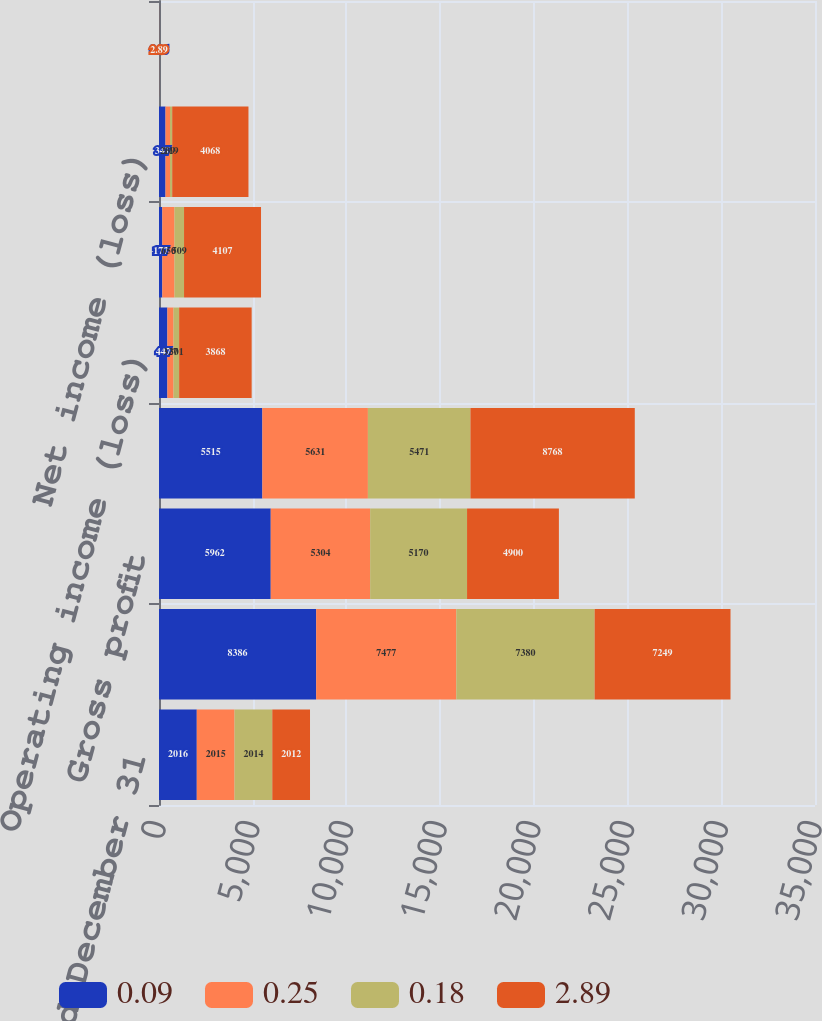Convert chart to OTSL. <chart><loc_0><loc_0><loc_500><loc_500><stacked_bar_chart><ecel><fcel>Year Ended December 31<fcel>Net sales<fcel>Gross profit<fcel>Total operating expenses<fcel>Operating income (loss)<fcel>Income (loss) before income<fcel>Net income (loss)<fcel>Basic<nl><fcel>0.09<fcel>2016<fcel>8386<fcel>5962<fcel>5515<fcel>447<fcel>177<fcel>347<fcel>0.26<nl><fcel>0.25<fcel>2015<fcel>7477<fcel>5304<fcel>5631<fcel>327<fcel>650<fcel>239<fcel>0.18<nl><fcel>0.18<fcel>2014<fcel>7380<fcel>5170<fcel>5471<fcel>301<fcel>509<fcel>119<fcel>0.09<nl><fcel>2.89<fcel>2012<fcel>7249<fcel>4900<fcel>8768<fcel>3868<fcel>4107<fcel>4068<fcel>2.89<nl></chart> 